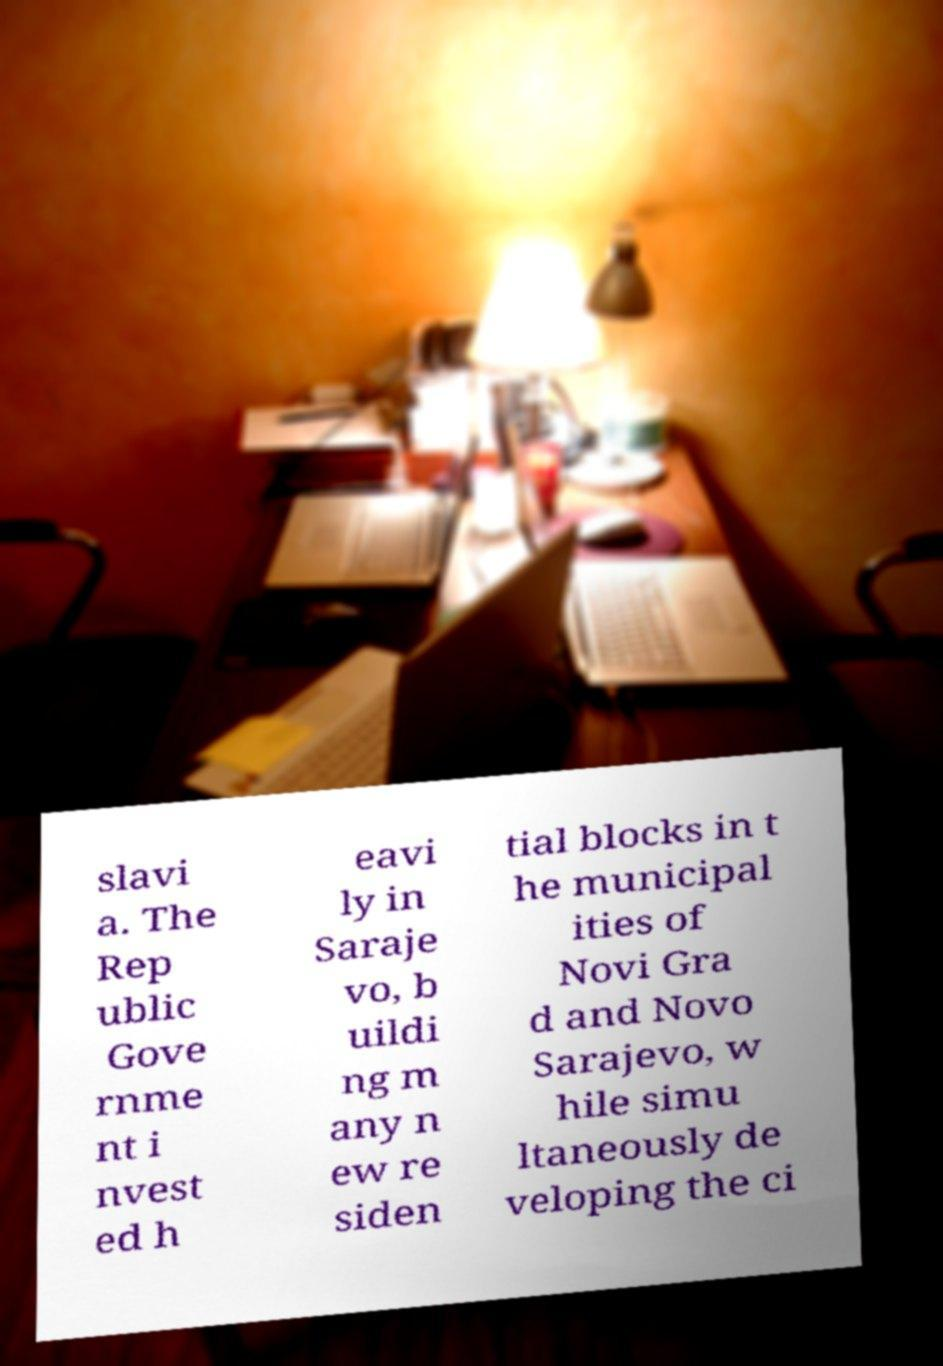Can you read and provide the text displayed in the image?This photo seems to have some interesting text. Can you extract and type it out for me? slavi a. The Rep ublic Gove rnme nt i nvest ed h eavi ly in Saraje vo, b uildi ng m any n ew re siden tial blocks in t he municipal ities of Novi Gra d and Novo Sarajevo, w hile simu ltaneously de veloping the ci 